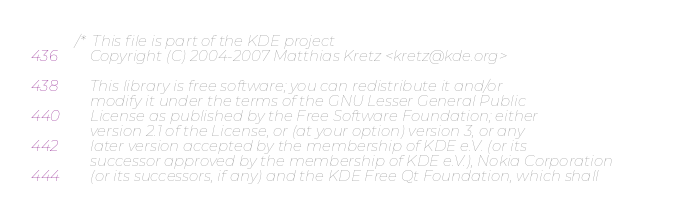<code> <loc_0><loc_0><loc_500><loc_500><_C_>/*  This file is part of the KDE project
    Copyright (C) 2004-2007 Matthias Kretz <kretz@kde.org>

    This library is free software; you can redistribute it and/or
    modify it under the terms of the GNU Lesser General Public
    License as published by the Free Software Foundation; either
    version 2.1 of the License, or (at your option) version 3, or any
    later version accepted by the membership of KDE e.V. (or its
    successor approved by the membership of KDE e.V.), Nokia Corporation 
    (or its successors, if any) and the KDE Free Qt Foundation, which shall</code> 